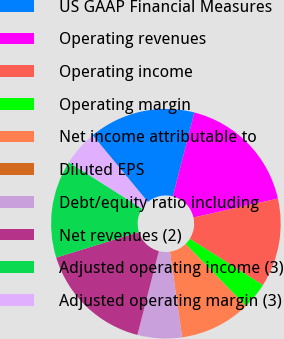<chart> <loc_0><loc_0><loc_500><loc_500><pie_chart><fcel>US GAAP Financial Measures<fcel>Operating revenues<fcel>Operating income<fcel>Operating margin<fcel>Net income attributable to<fcel>Diluted EPS<fcel>Debt/equity ratio including<fcel>Net revenues (2)<fcel>Adjusted operating income (3)<fcel>Adjusted operating margin (3)<nl><fcel>15.0%<fcel>17.5%<fcel>12.5%<fcel>3.75%<fcel>10.0%<fcel>0.01%<fcel>6.25%<fcel>16.25%<fcel>13.75%<fcel>5.0%<nl></chart> 